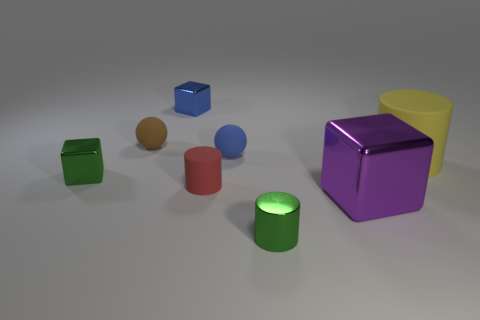Add 1 big purple matte things. How many objects exist? 9 Subtract all cylinders. How many objects are left? 5 Add 4 matte cylinders. How many matte cylinders are left? 6 Add 4 tiny blocks. How many tiny blocks exist? 6 Subtract 0 brown cylinders. How many objects are left? 8 Subtract all small red rubber objects. Subtract all blue spheres. How many objects are left? 6 